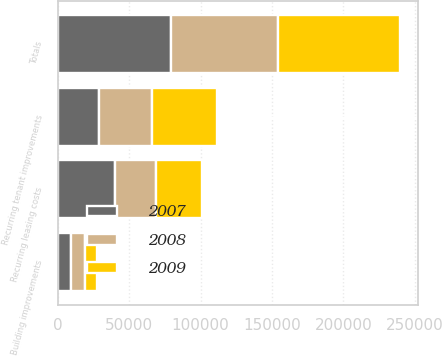<chart> <loc_0><loc_0><loc_500><loc_500><stacked_bar_chart><ecel><fcel>Recurring tenant improvements<fcel>Recurring leasing costs<fcel>Building improvements<fcel>Totals<nl><fcel>2007<fcel>29321<fcel>40412<fcel>9321<fcel>79054<nl><fcel>2008<fcel>36885<fcel>28205<fcel>9724<fcel>74814<nl><fcel>2009<fcel>45296<fcel>32238<fcel>8402<fcel>85936<nl></chart> 